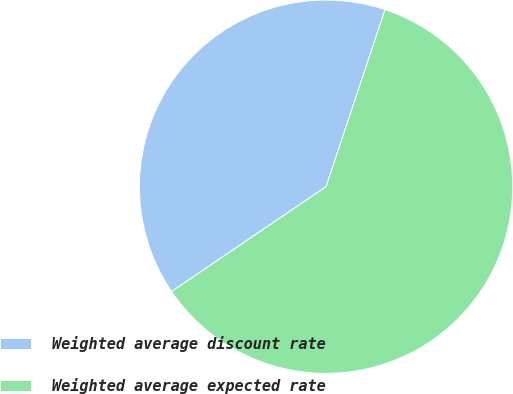<chart> <loc_0><loc_0><loc_500><loc_500><pie_chart><fcel>Weighted average discount rate<fcel>Weighted average expected rate<nl><fcel>39.61%<fcel>60.39%<nl></chart> 